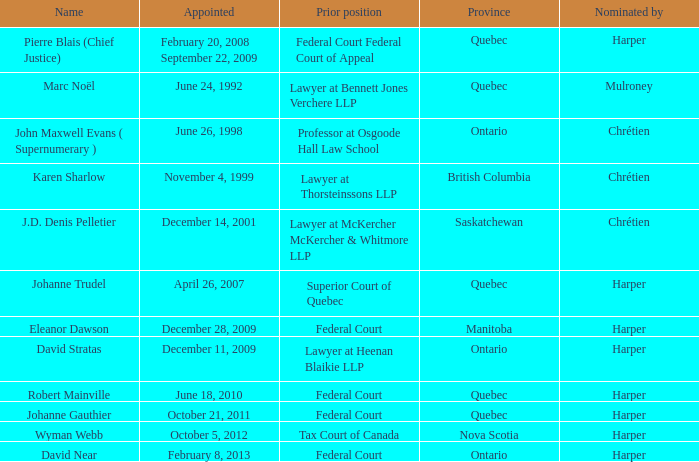Who was appointed on October 21, 2011 from Quebec? Johanne Gauthier. 